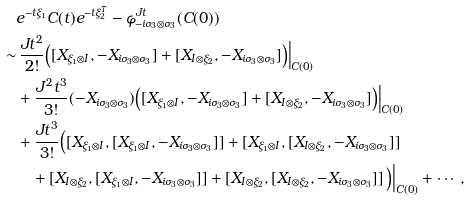Convert formula to latex. <formula><loc_0><loc_0><loc_500><loc_500>& e ^ { - t \xi _ { 1 } } C ( t ) e ^ { - t \xi _ { 2 } ^ { T } } - \varphi _ { - i \sigma _ { 3 } \otimes \sigma _ { 3 } } ^ { J t } ( C ( 0 ) ) \\ \sim & \, \frac { J t ^ { 2 } } { 2 ! } \Big ( [ X _ { \xi _ { 1 } \otimes I } , - X _ { i \sigma _ { 3 } \otimes \sigma _ { 3 } } ] + [ X _ { I \otimes \xi _ { 2 } } , - X _ { i \sigma _ { 3 } \otimes \sigma _ { 3 } } ] \Big ) \Big | _ { C ( 0 ) } \\ & + \frac { J ^ { 2 } t ^ { 3 } } { 3 ! } ( - X _ { i \sigma _ { 3 } \otimes \sigma _ { 3 } } ) \Big ( [ X _ { \xi _ { 1 } \otimes I } , - X _ { i \sigma _ { 3 } \otimes \sigma _ { 3 } } ] + [ X _ { I \otimes \xi _ { 2 } } , - X _ { i \sigma _ { 3 } \otimes \sigma _ { 3 } } ] \Big ) \Big | _ { C ( 0 ) } \\ & + \frac { J t ^ { 3 } } { 3 ! } \Big ( [ X _ { \xi _ { 1 } \otimes I } , [ X _ { \xi _ { 1 } \otimes I } , - X _ { i \sigma _ { 3 } \otimes \sigma _ { 3 } } ] ] + [ X _ { \xi _ { 1 } \otimes I } , [ X _ { I \otimes \xi _ { 2 } } , - X _ { i \sigma _ { 3 } \otimes \sigma _ { 3 } } ] ] \\ & \quad + [ X _ { I \otimes \xi _ { 2 } } , [ X _ { \xi _ { 1 } \otimes I } , - X _ { i \sigma _ { 3 } \otimes \sigma _ { 3 } } ] ] + [ X _ { I \otimes \xi _ { 2 } } , [ X _ { I \otimes \xi _ { 2 } } , - X _ { i \sigma _ { 3 } \otimes \sigma _ { 3 } } ] ] \, \Big ) \Big | _ { C ( 0 ) } + \cdots ,</formula> 